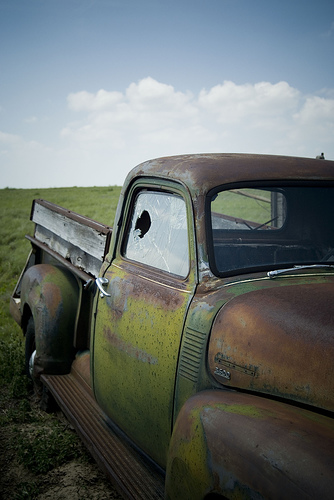<image>
Can you confirm if the grass is behind the car? Yes. From this viewpoint, the grass is positioned behind the car, with the car partially or fully occluding the grass. 